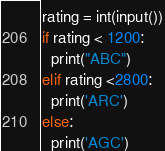Convert code to text. <code><loc_0><loc_0><loc_500><loc_500><_Python_>rating = int(input())
if rating < 1200:
  print("ABC")
elif rating <2800:
  print('ARC')
else:
  print('AGC')</code> 